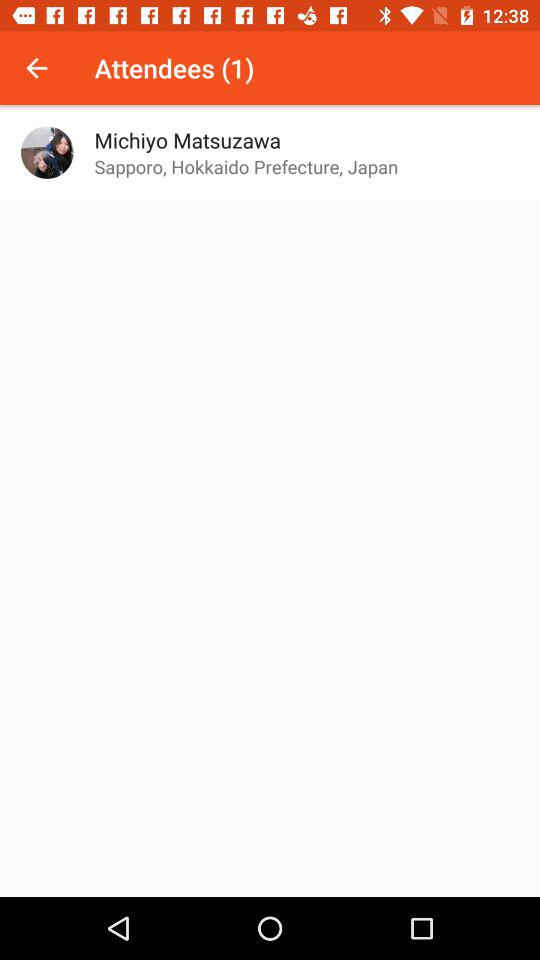What is the location of the user? The location of the user is "Sapporo, Hokkaido Prefecture, Japan". 